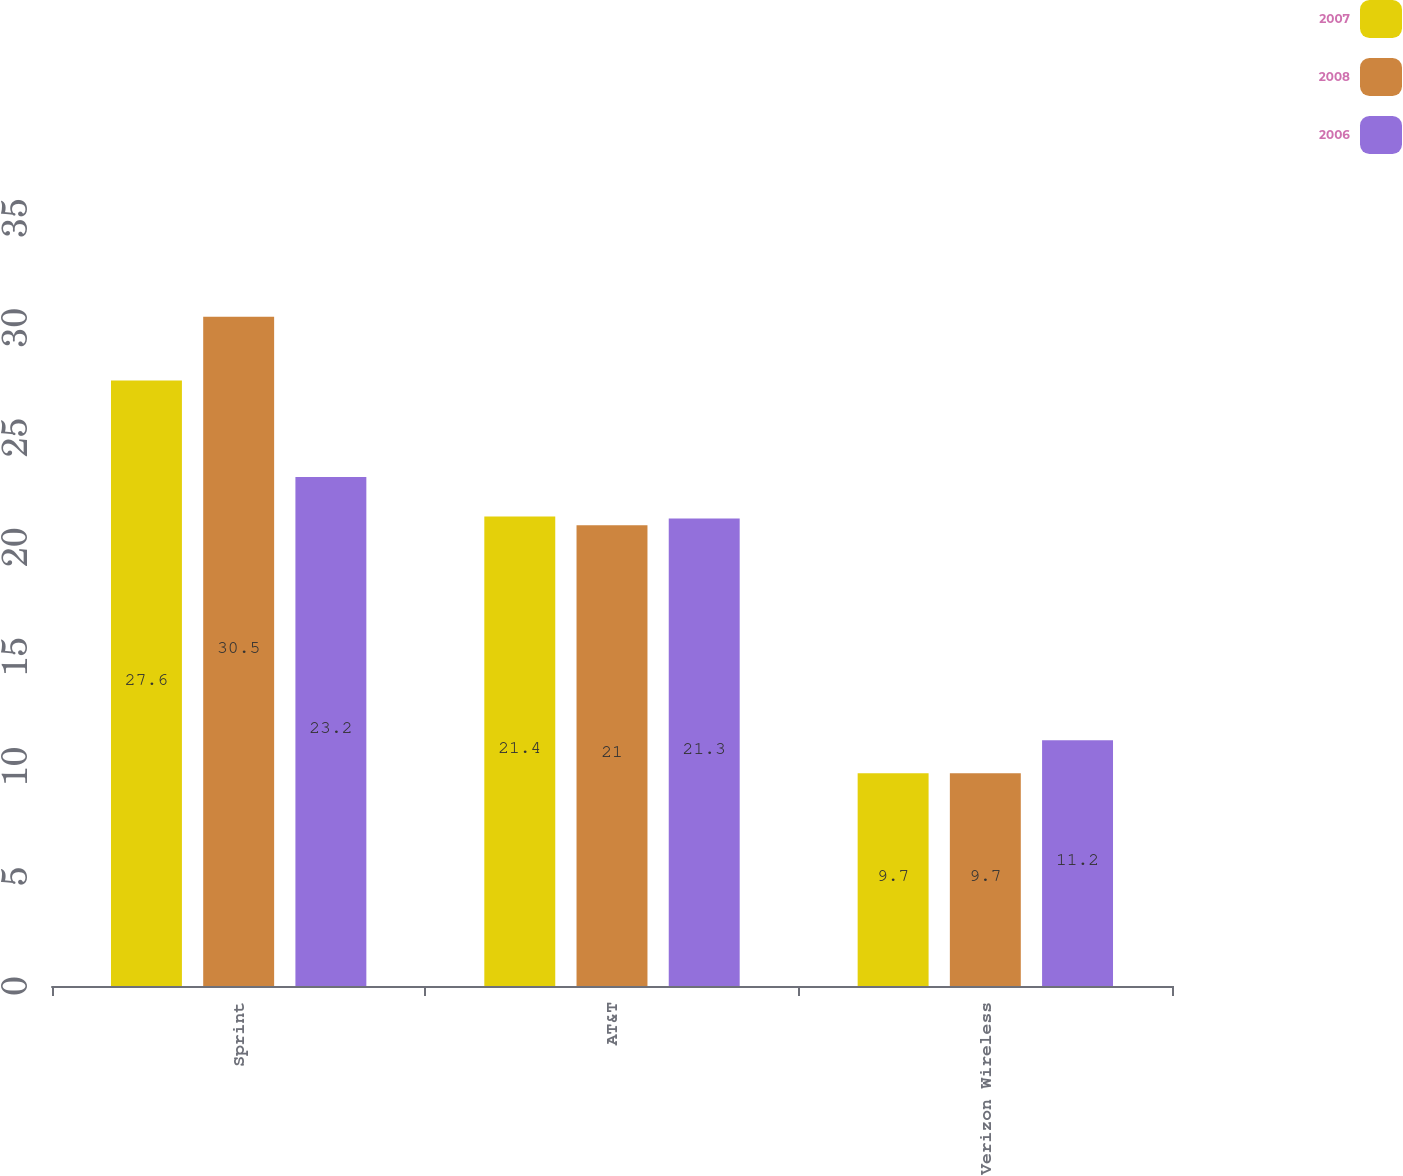<chart> <loc_0><loc_0><loc_500><loc_500><stacked_bar_chart><ecel><fcel>Sprint<fcel>AT&T<fcel>Verizon Wireless<nl><fcel>2007<fcel>27.6<fcel>21.4<fcel>9.7<nl><fcel>2008<fcel>30.5<fcel>21<fcel>9.7<nl><fcel>2006<fcel>23.2<fcel>21.3<fcel>11.2<nl></chart> 